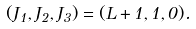Convert formula to latex. <formula><loc_0><loc_0><loc_500><loc_500>( J _ { 1 } , J _ { 2 } , J _ { 3 } ) = ( L + 1 , 1 , 0 ) .</formula> 